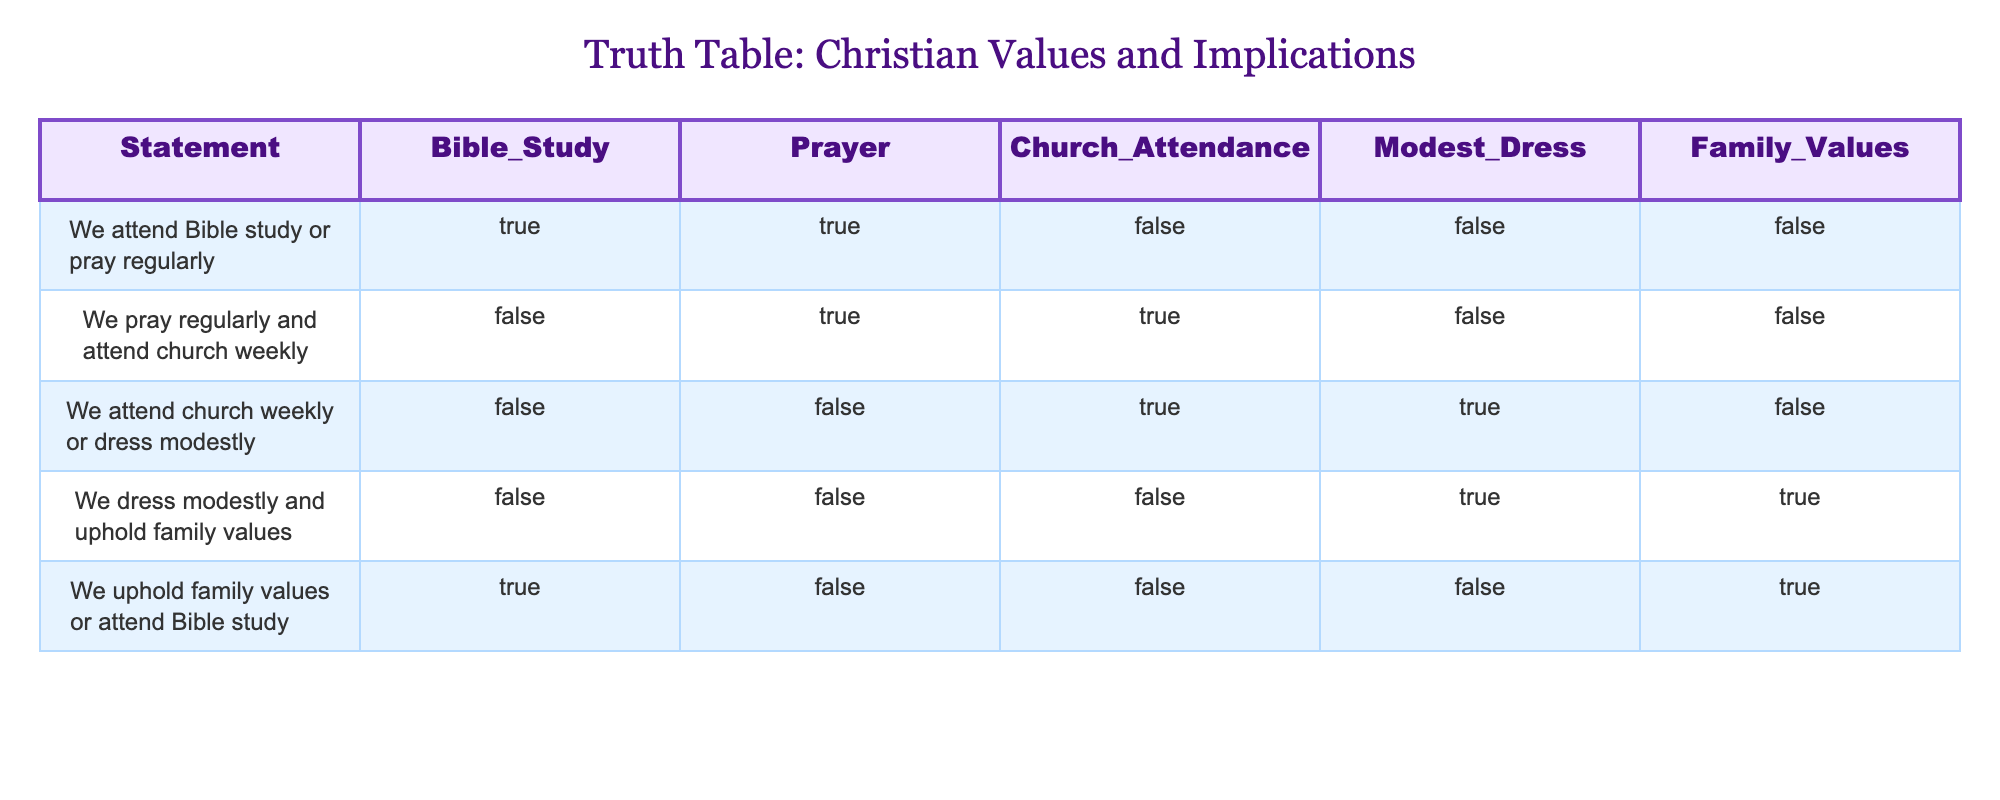What statement corresponds to regular attendance at Bible study and church? In the table, we can look at the row where both Bible study and Church Attendance are marked as True. This corresponds to the statement "We pray regularly and attend church weekly."
Answer: We pray regularly and attend church weekly Is there a statement that implies attending Bible study or dressing modestly? We need to find a row where either Bible Study or Modest Dress is marked as True. The only row that meets this criteria is "We attend church weekly or dress modestly" since the Modest Dress column is True there.
Answer: Yes What will happen if we dress modestly and uphold family values? The statement "We dress modestly and uphold family values" implies both conditions must be True. From the table, we can see it is marked as False, meaning at least one of those conditions is not being met in this case.
Answer: Nothing significant, as it's marked as False Which two statements imply prayer or attendance at Bible study? We should search for rows that have either Prayer or Bible Study marked as True. The relevant statements are "We attend Bible study or pray regularly" and "We uphold family values or attend Bible study". Both have conditions that fit the criteria of implicating prayer or Bible study.
Answer: "We attend Bible study or pray regularly" and "We uphold family values or attend Bible study" What conditions must be met to claim we uphold family values? To claim we uphold family values based on the table's data, we need to look for a True value in the Family Values column. The row marked "We dress modestly and uphold family values" confirms that both modest dress and family values are true, hence we can validate that claim.
Answer: Both modest dress and family values must be true 